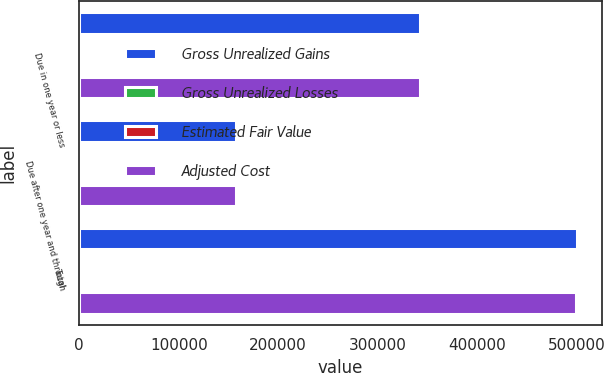<chart> <loc_0><loc_0><loc_500><loc_500><stacked_bar_chart><ecel><fcel>Due in one year or less<fcel>Due after one year and through<fcel>Total<nl><fcel>Gross Unrealized Gains<fcel>342673<fcel>157594<fcel>500267<nl><fcel>Gross Unrealized Losses<fcel>15<fcel>84<fcel>99<nl><fcel>Estimated Fair Value<fcel>188<fcel>219<fcel>407<nl><fcel>Adjusted Cost<fcel>342500<fcel>157459<fcel>499959<nl></chart> 